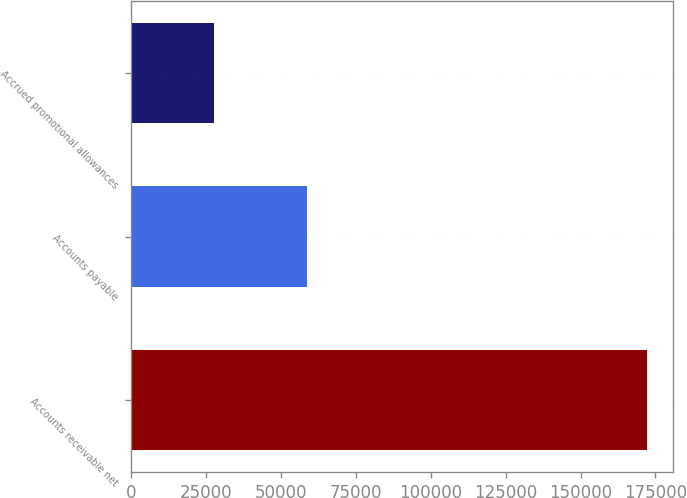<chart> <loc_0><loc_0><loc_500><loc_500><bar_chart><fcel>Accounts receivable net<fcel>Accounts payable<fcel>Accrued promotional allowances<nl><fcel>172201<fcel>58579<fcel>27544<nl></chart> 